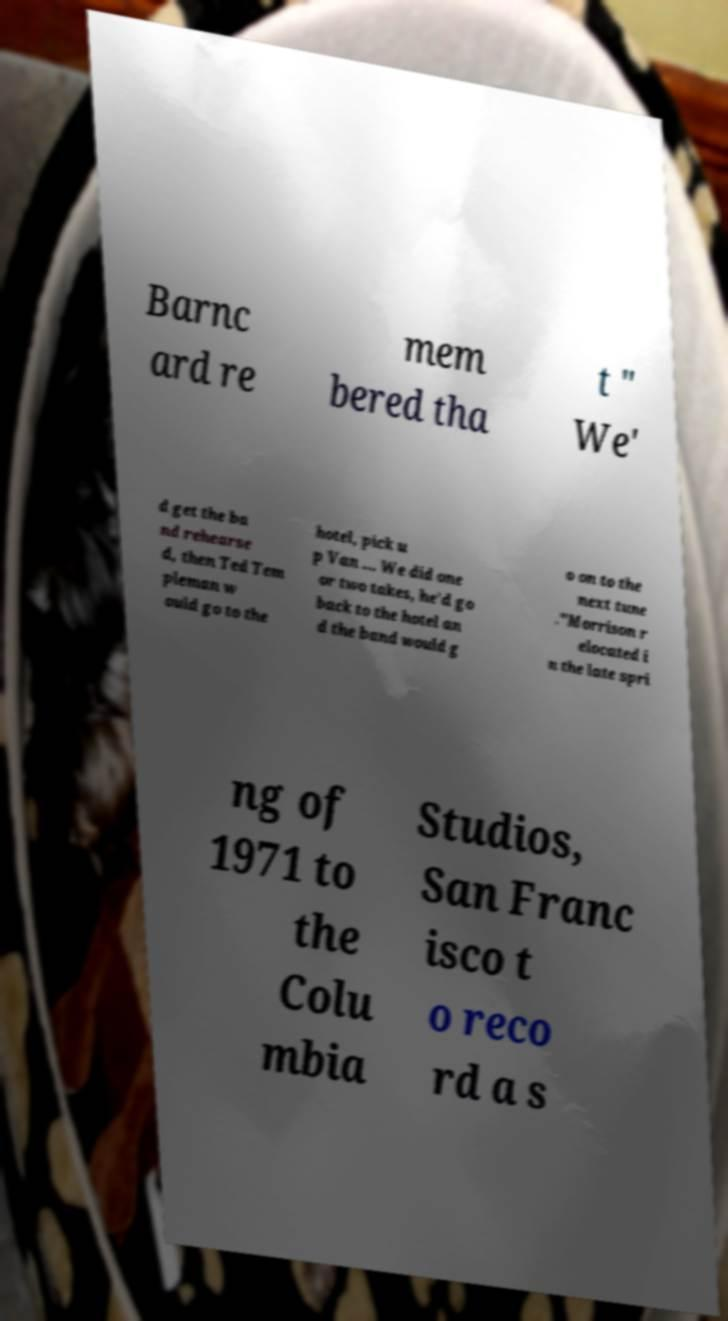What messages or text are displayed in this image? I need them in a readable, typed format. Barnc ard re mem bered tha t " We' d get the ba nd rehearse d, then Ted Tem pleman w ould go to the hotel, pick u p Van ... We did one or two takes, he'd go back to the hotel an d the band would g o on to the next tune ."Morrison r elocated i n the late spri ng of 1971 to the Colu mbia Studios, San Franc isco t o reco rd a s 